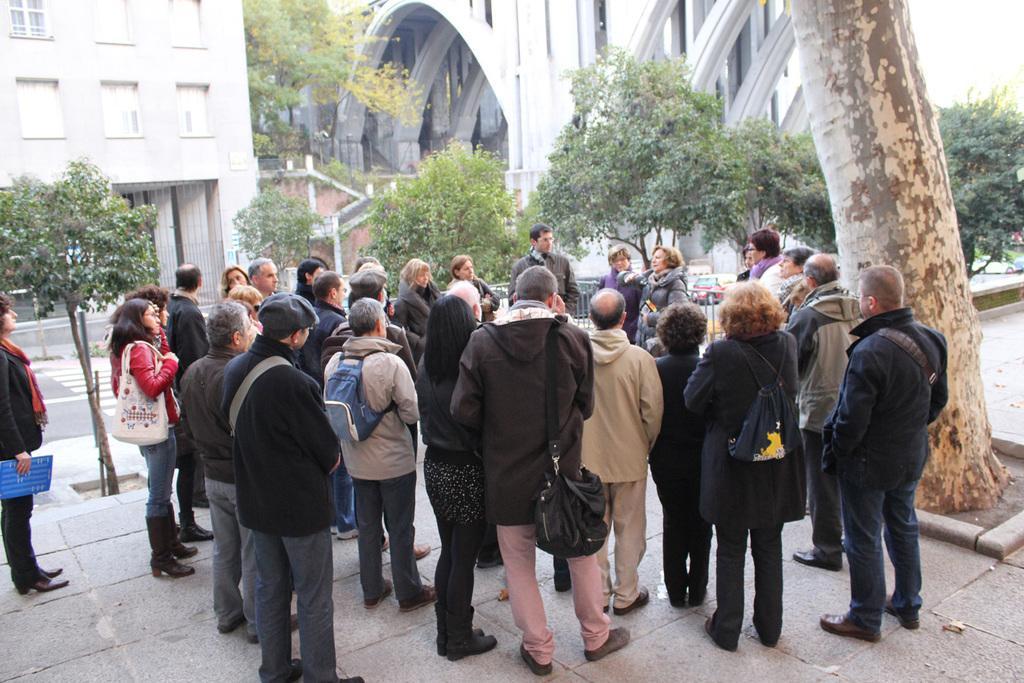Could you give a brief overview of what you see in this image? In this image there are people standing on a footpath, in the background there are trees, road and buildings. 